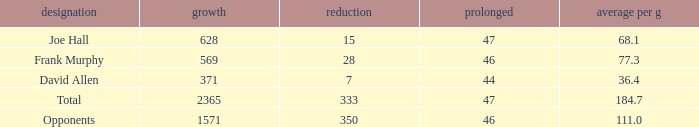Could you parse the entire table? {'header': ['designation', 'growth', 'reduction', 'prolonged', 'average per g'], 'rows': [['Joe Hall', '628', '15', '47', '68.1'], ['Frank Murphy', '569', '28', '46', '77.3'], ['David Allen', '371', '7', '44', '36.4'], ['Total', '2365', '333', '47', '184.7'], ['Opponents', '1571', '350', '46', '111.0']]} How much Avg/G has a Gain smaller than 1571, and a Long smaller than 46? 1.0. 